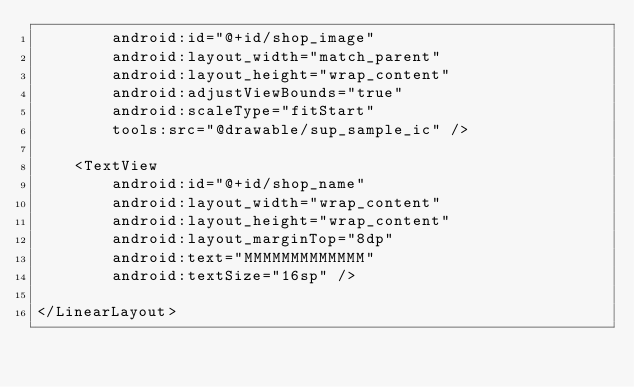Convert code to text. <code><loc_0><loc_0><loc_500><loc_500><_XML_>        android:id="@+id/shop_image"
        android:layout_width="match_parent"
        android:layout_height="wrap_content"
        android:adjustViewBounds="true"
        android:scaleType="fitStart"
        tools:src="@drawable/sup_sample_ic" />

    <TextView
        android:id="@+id/shop_name"
        android:layout_width="wrap_content"
        android:layout_height="wrap_content"
        android:layout_marginTop="8dp"
        android:text="MMMMMMMMMMMMM"
        android:textSize="16sp" />

</LinearLayout></code> 